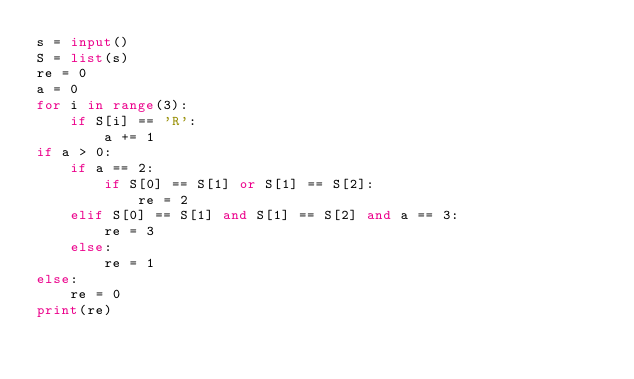<code> <loc_0><loc_0><loc_500><loc_500><_Python_>s = input()
S = list(s)
re = 0
a = 0
for i in range(3):
    if S[i] == 'R':
        a += 1
if a > 0:
    if a == 2:
        if S[0] == S[1] or S[1] == S[2]:
            re = 2
    elif S[0] == S[1] and S[1] == S[2] and a == 3:
        re = 3
    else:
        re = 1
else:
    re = 0
print(re)</code> 